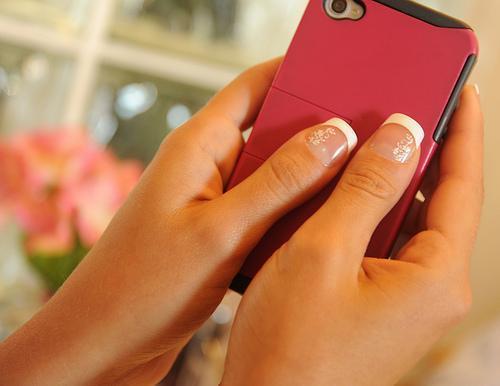How many people are in the photo?
Give a very brief answer. 1. How many hands are in the photo?
Give a very brief answer. 2. 